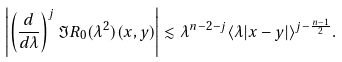<formula> <loc_0><loc_0><loc_500><loc_500>\left | \left ( \frac { d } { d \lambda } \right ) ^ { j } \Im R _ { 0 } ( \lambda ^ { 2 } ) ( x , y ) \right | \lesssim \lambda ^ { n - 2 - j } \langle \lambda | x - y | \rangle ^ { j - \frac { n - 1 } 2 } .</formula> 